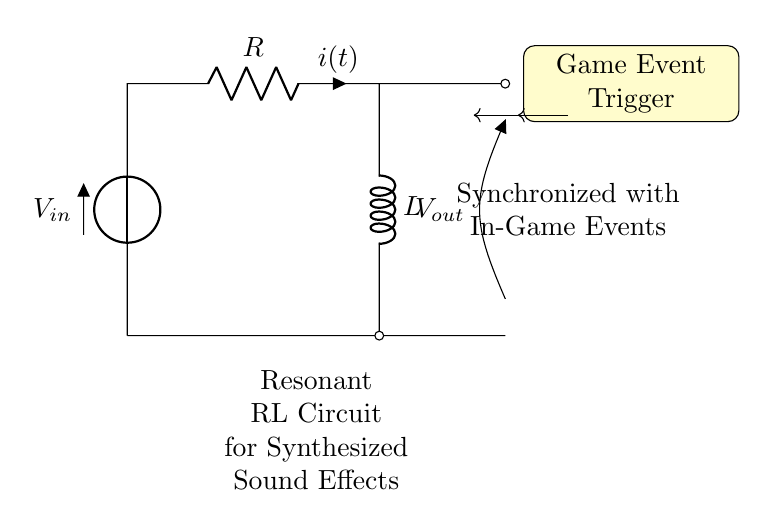What is the input voltage of the circuit? The input voltage is labeled as V_in, which is the voltage source connected to the circuit. It supplies electrical energy necessary for the circuit operation.
Answer: V_in What components are present in the circuit? There are two main components in the circuit: a resistor denoted as R and an inductor denoted as L, both connected in series.
Answer: Resistor and Inductor What type of circuit is this? The circuit is a resonant RL circuit which comprises a resistor and an inductor. It is specifically designed to generate sound effects dynamically synchronized with game events.
Answer: Resonant RL circuit What is the current flowing through the circuit? The current flowing through the circuit is represented as i(t), indicating it is a function of time and is influenced by the circuit components R and L.
Answer: i(t) How does this circuit relate to game events? The circuit is triggered by a game event as indicated by the "Game Event Trigger" node, which means that in-game occurrences can activate this circuit to produce sound effects.
Answer: Synchronized with game events What is the relationship between voltage and current in this circuit? The relationship is described by Ohm's Law (V = IR) for the resistor in conjunction with the inductor's behavior, where the voltage across the inductor is proportional to the rate of change of current through it.
Answer: Ohm's Law and Inductor behavior 